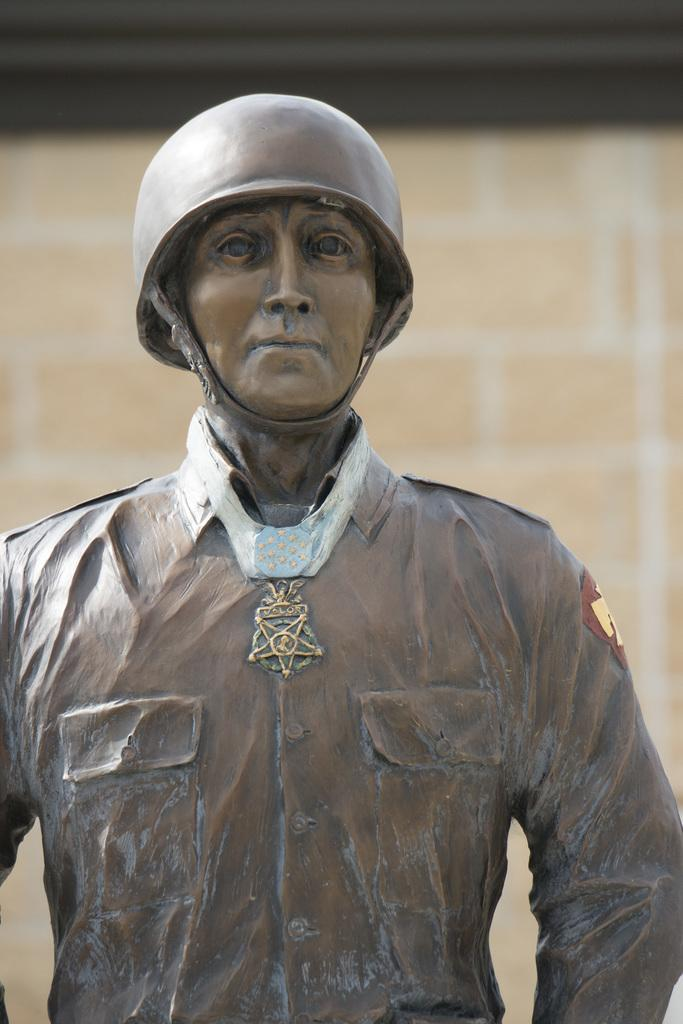What is the main subject in the image? There is a statue in the image. Can you describe the setting of the image? There is a wall in the background of the image. What is the sister of the statue doing in the image? There is no mention of a sister in the image, and the statue is the main subject. 